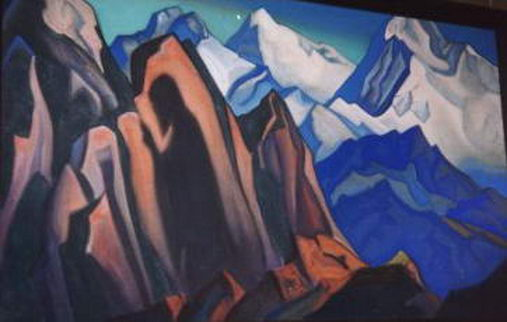Write a detailed description of the given image. The given image illustrates a striking mountain landscape meticulously rendered in a cubist style. The artist employs geometric shapes to craft the mountains and rocks, which deepens the dimensionality and enriches the composition. The color scheme is dominated by cool blues and purples, interspersed with warm oranges, lending vibrancy and dynamism to the scene. The light blue sky provides a striking contrast against the darker blue mountains, enhancing the overall visual impact profoundly. This landscape artwork delves into the natural world and outdoor scenery, offering a unique cubist interpretation that combines abstract forms and various perspectives to reimagine traditional landscapes in a compelling and intriguing manner. 